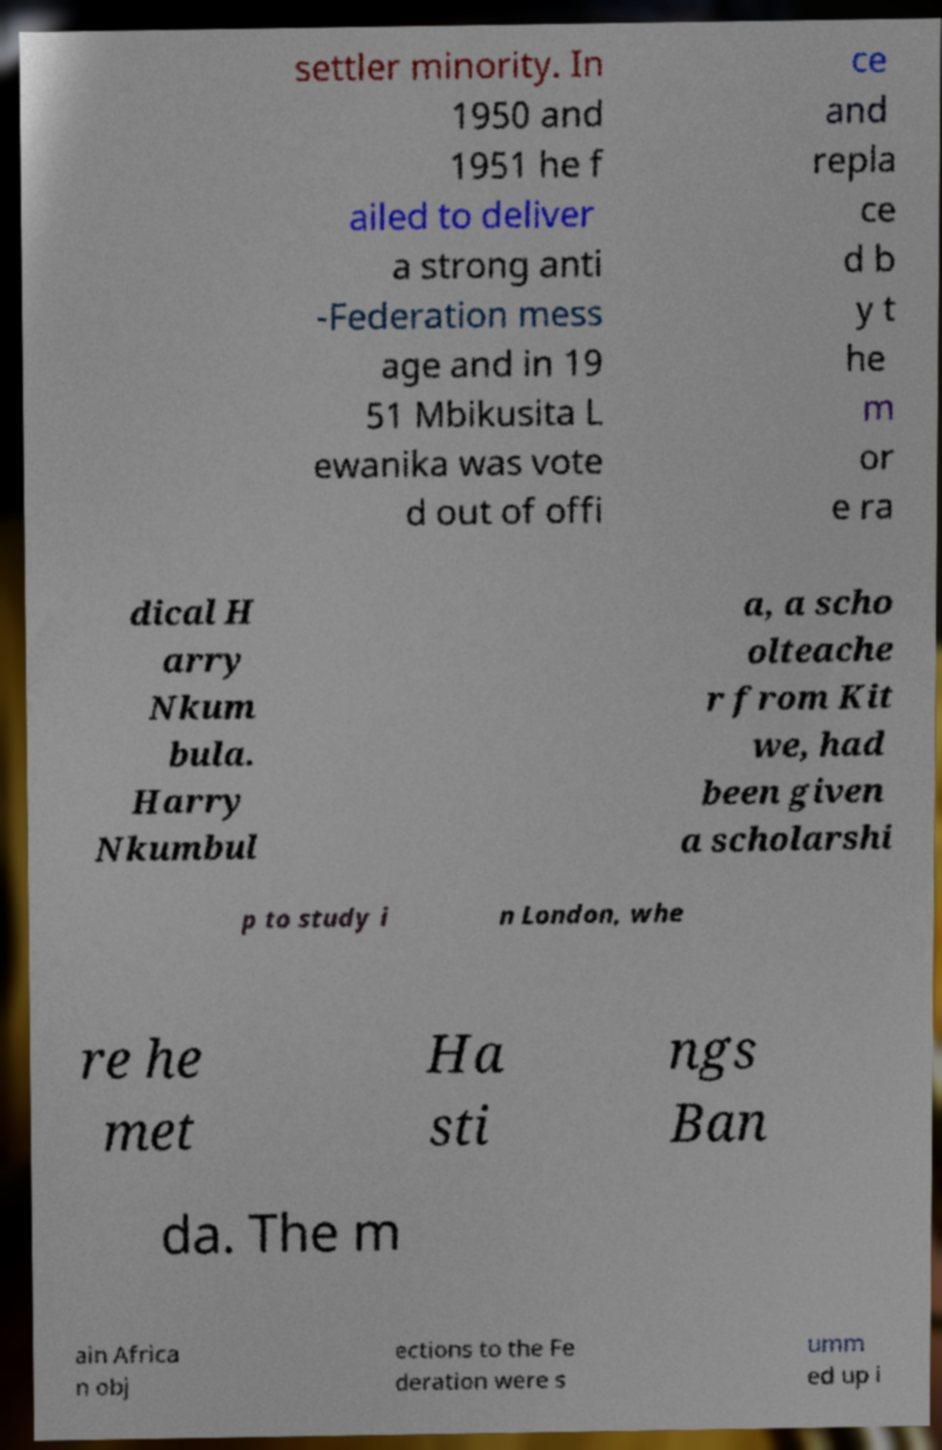Could you extract and type out the text from this image? settler minority. In 1950 and 1951 he f ailed to deliver a strong anti -Federation mess age and in 19 51 Mbikusita L ewanika was vote d out of offi ce and repla ce d b y t he m or e ra dical H arry Nkum bula. Harry Nkumbul a, a scho olteache r from Kit we, had been given a scholarshi p to study i n London, whe re he met Ha sti ngs Ban da. The m ain Africa n obj ections to the Fe deration were s umm ed up i 